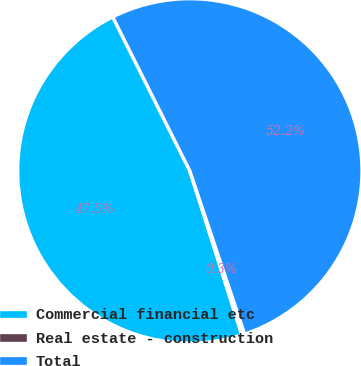<chart> <loc_0><loc_0><loc_500><loc_500><pie_chart><fcel>Commercial financial etc<fcel>Real estate - construction<fcel>Total<nl><fcel>47.49%<fcel>0.28%<fcel>52.23%<nl></chart> 